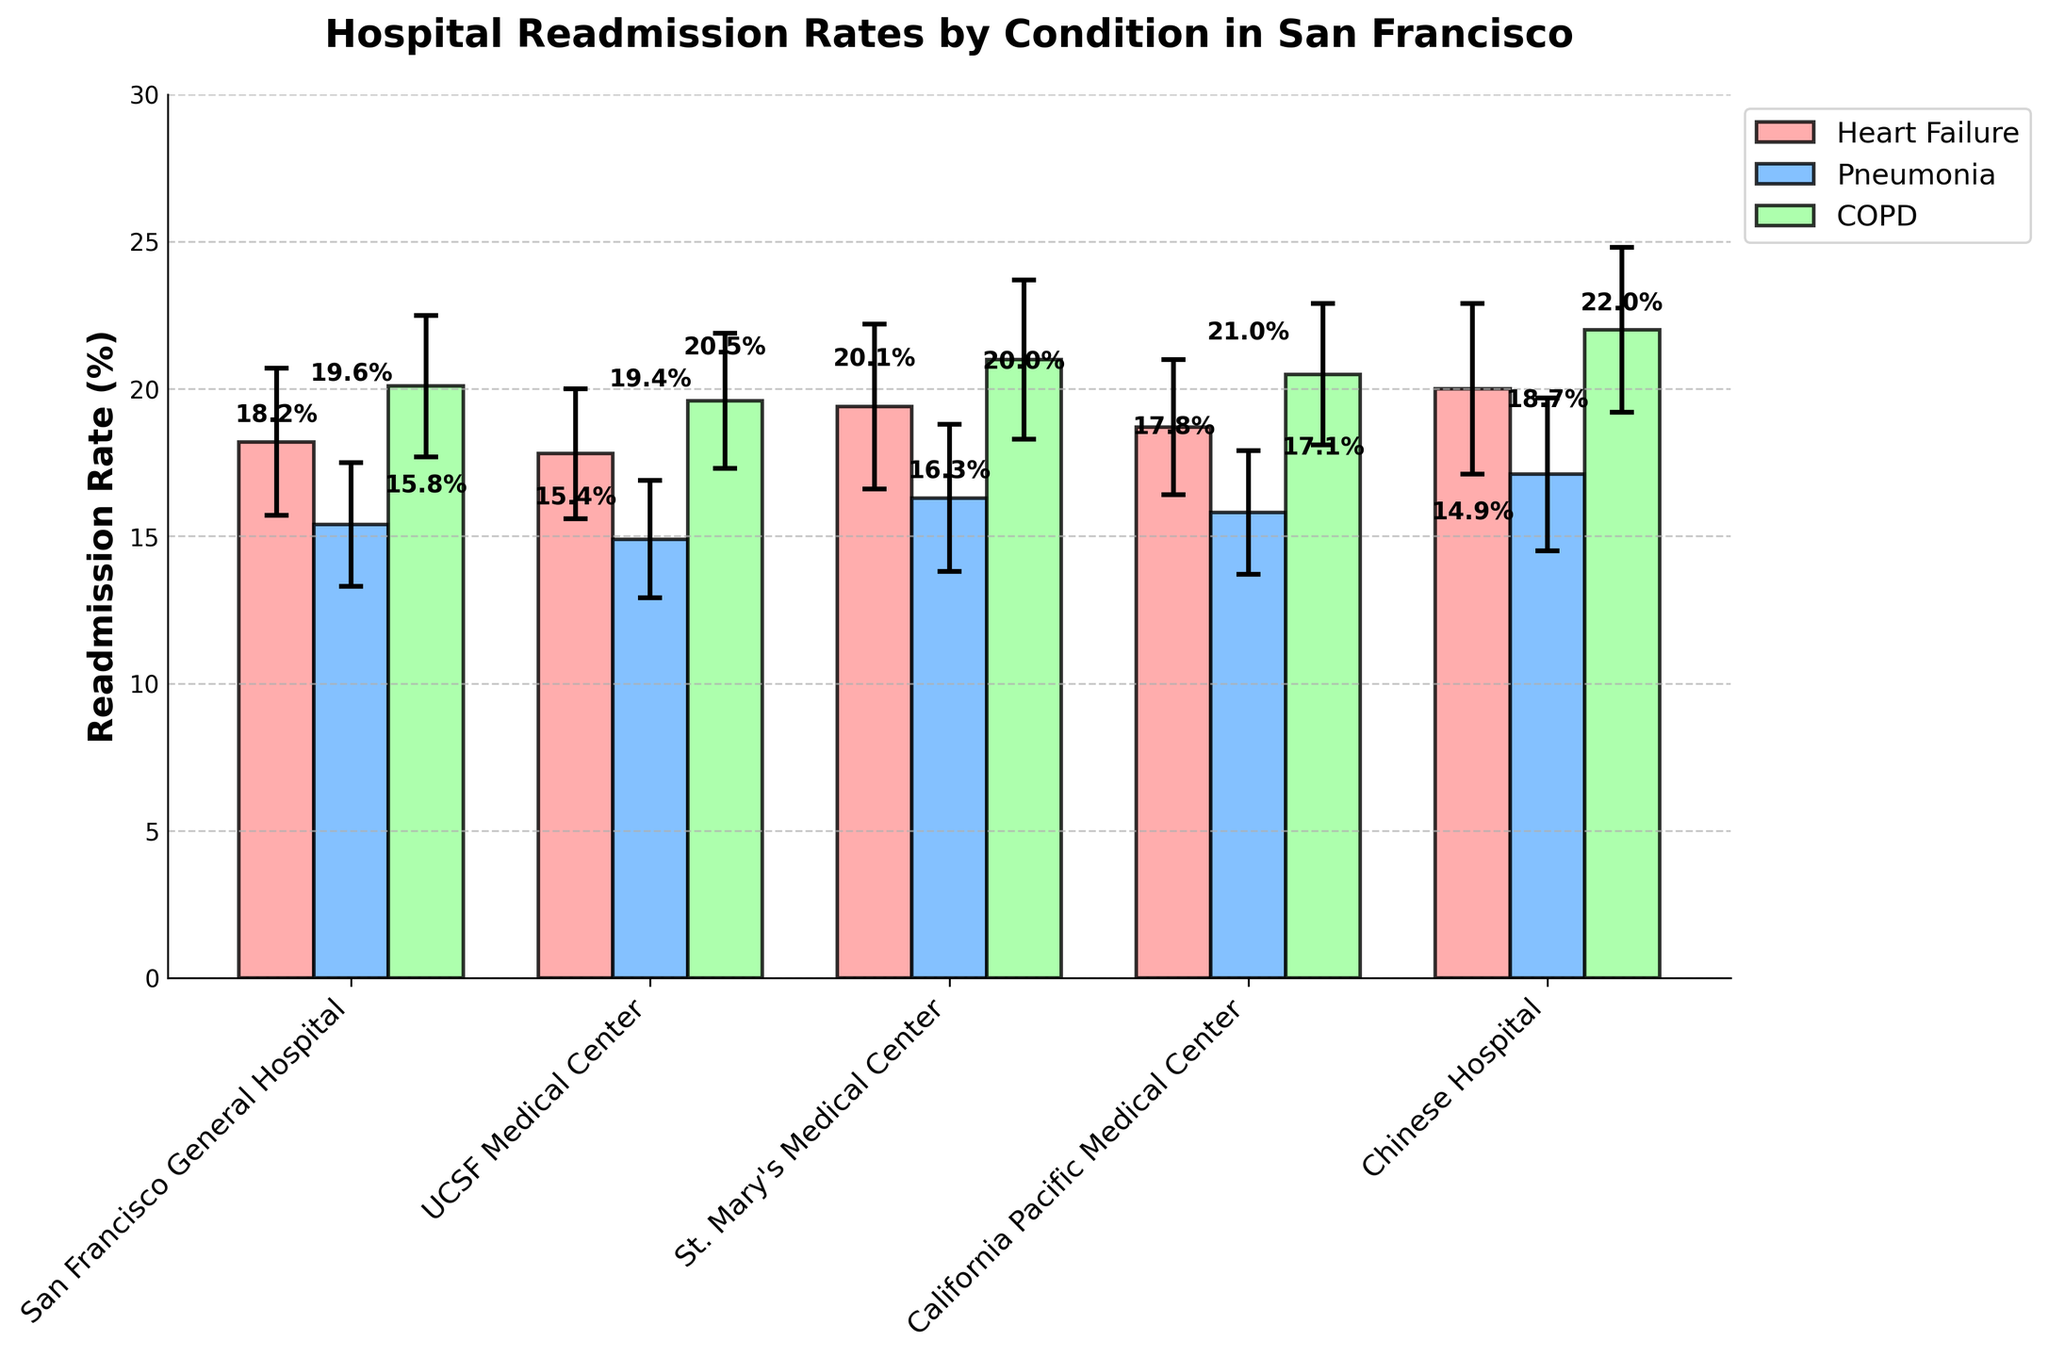What's the title of the bar chart? The title of the chart is generally found at the top and gives a brief description of what the chart represents. In this case, the title is clearly visible.
Answer: Hospital Readmission Rates by Condition in San Francisco Which hospital has the highest readmission rate for COPD? Locate the bar for COPD for each hospital using the legend. Compare all the heights of these specific bars.
Answer: Chinese Hospital What is the readmission rate for heart failure at UCSF Medical Center? Find the bar that represents heart failure for UCSF Medical Center by matching the hospital labels on the x-axis and the condition based on the color indicated in the legend.
Answer: 17.8% Which condition has the lowest average readmission rate across all hospitals? Calculate the average rate for each condition across hospitals. Sum the readmission rates for each condition and divide by the number of hospitals, then compare.
Answer: Pneumonia Are there any hospitals where the readmission rate for pneumonia is higher than for heart failure? Compare the heights of the bars for pneumonia and heart failure within each hospital group. Check if any pneumonia bars are taller than the corresponding heart failure bars.
Answer: Yes, Chinese Hospital What is the difference in the readmission rates for heart failure between San Francisco General Hospital and St. Mary’s Medical Center? Subtract the readmission rate for heart failure at San Francisco General Hospital from the rate at St. Mary's Medical Center.
Answer: 1.2% Which hospital has the smallest error bar for pneumonia? Check the length of the error bars for pneumonia across all hospitals and find the smallest one.
Answer: UCSF Medical Center What are the overall trends in readmission rates for COPD across the hospitals? Look at the COPD readmission rates for all hospitals and summarize the general trend, observing if rates are generally high or low.
Answer: Rates are relatively high, ranging from 19.6% to 22.0% Is there a significant difference in the readmission rates for heart failure compared to COPD at California Pacific Medical Center? Compare the height of the bars for heart failure and COPD visually or calculate the difference if needed.
Answer: Yes, COPD rate is higher by 1.8% What is the error margin for the readmission rate of pneumonia at Chinese Hospital? Locate the error bar for pneumonia at Chinese Hospital and note the value.
Answer: 2.6% 